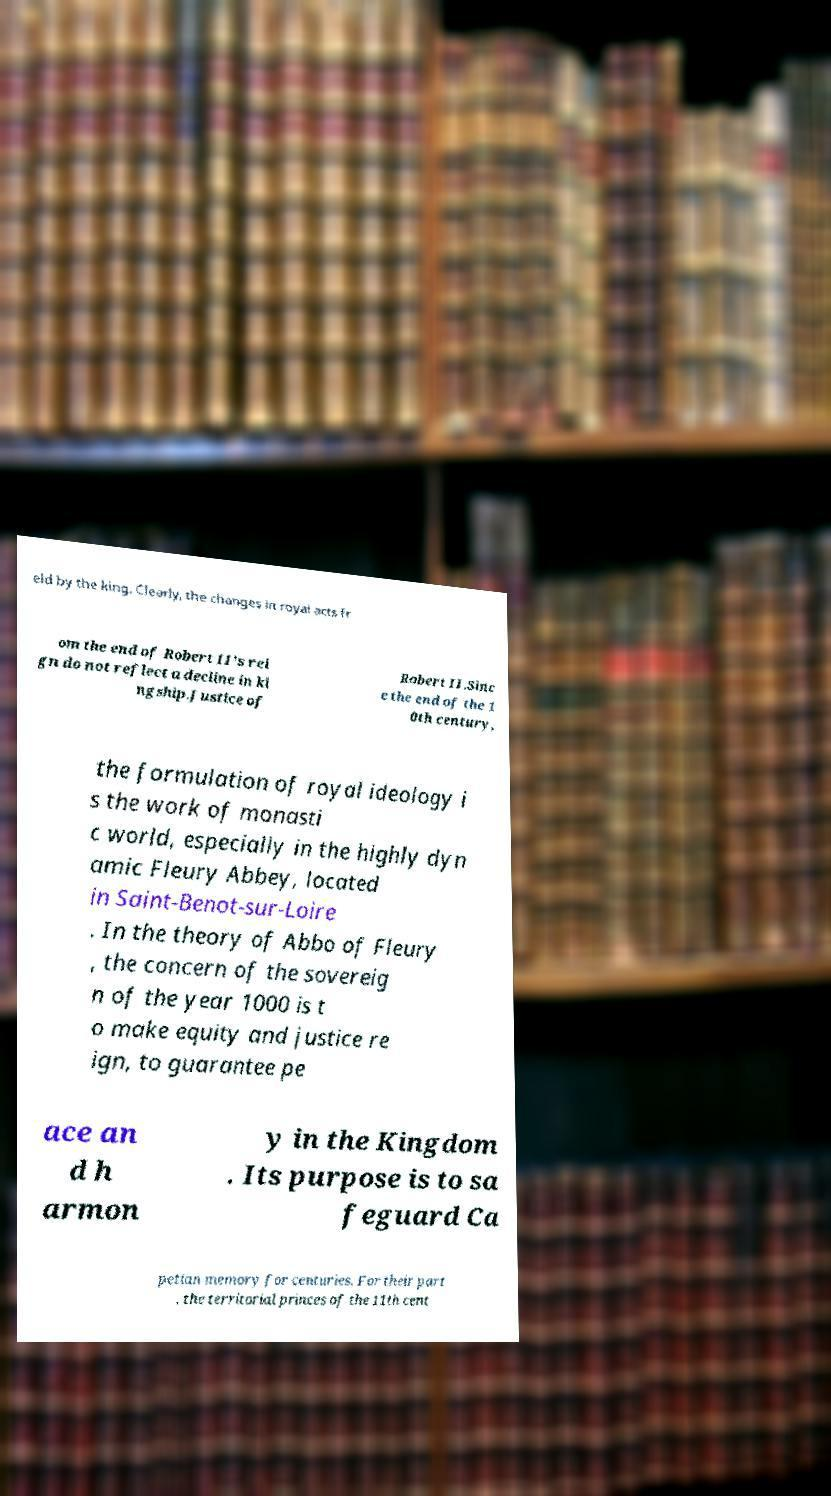Please read and relay the text visible in this image. What does it say? eld by the king. Clearly, the changes in royal acts fr om the end of Robert II's rei gn do not reflect a decline in ki ngship.Justice of Robert II.Sinc e the end of the 1 0th century, the formulation of royal ideology i s the work of monasti c world, especially in the highly dyn amic Fleury Abbey, located in Saint-Benot-sur-Loire . In the theory of Abbo of Fleury , the concern of the sovereig n of the year 1000 is t o make equity and justice re ign, to guarantee pe ace an d h armon y in the Kingdom . Its purpose is to sa feguard Ca petian memory for centuries. For their part , the territorial princes of the 11th cent 